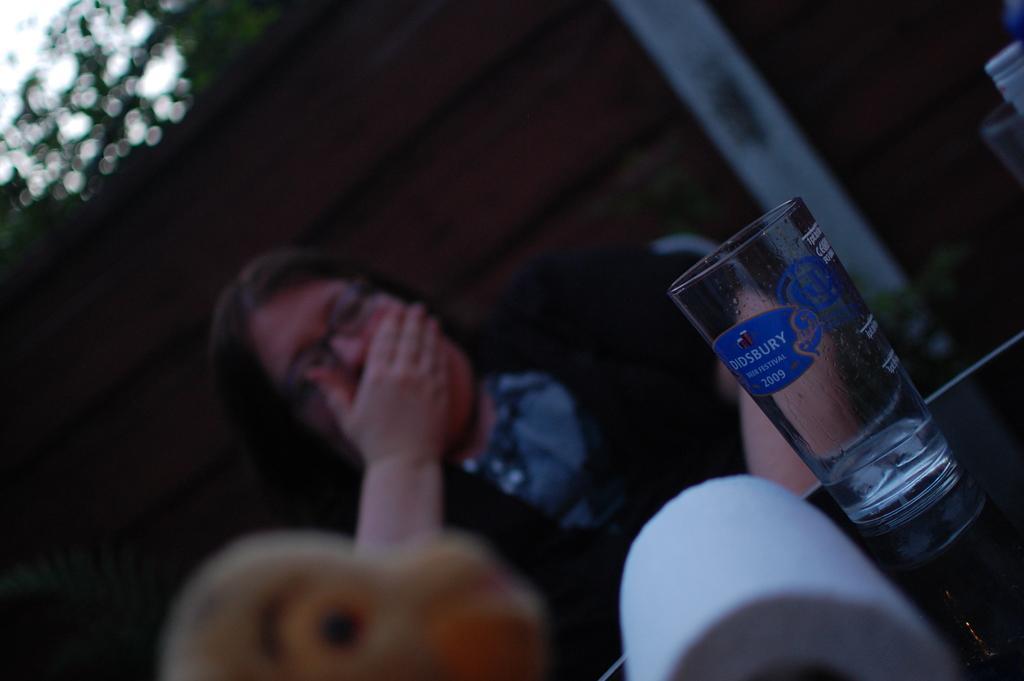Can you describe this image briefly? In this image there is a glass table on which there is a glass. Beside the glass there is a tissue roll. In the background there is a woman who closed her mouth with the hand. Behind the woman there is a wall. 